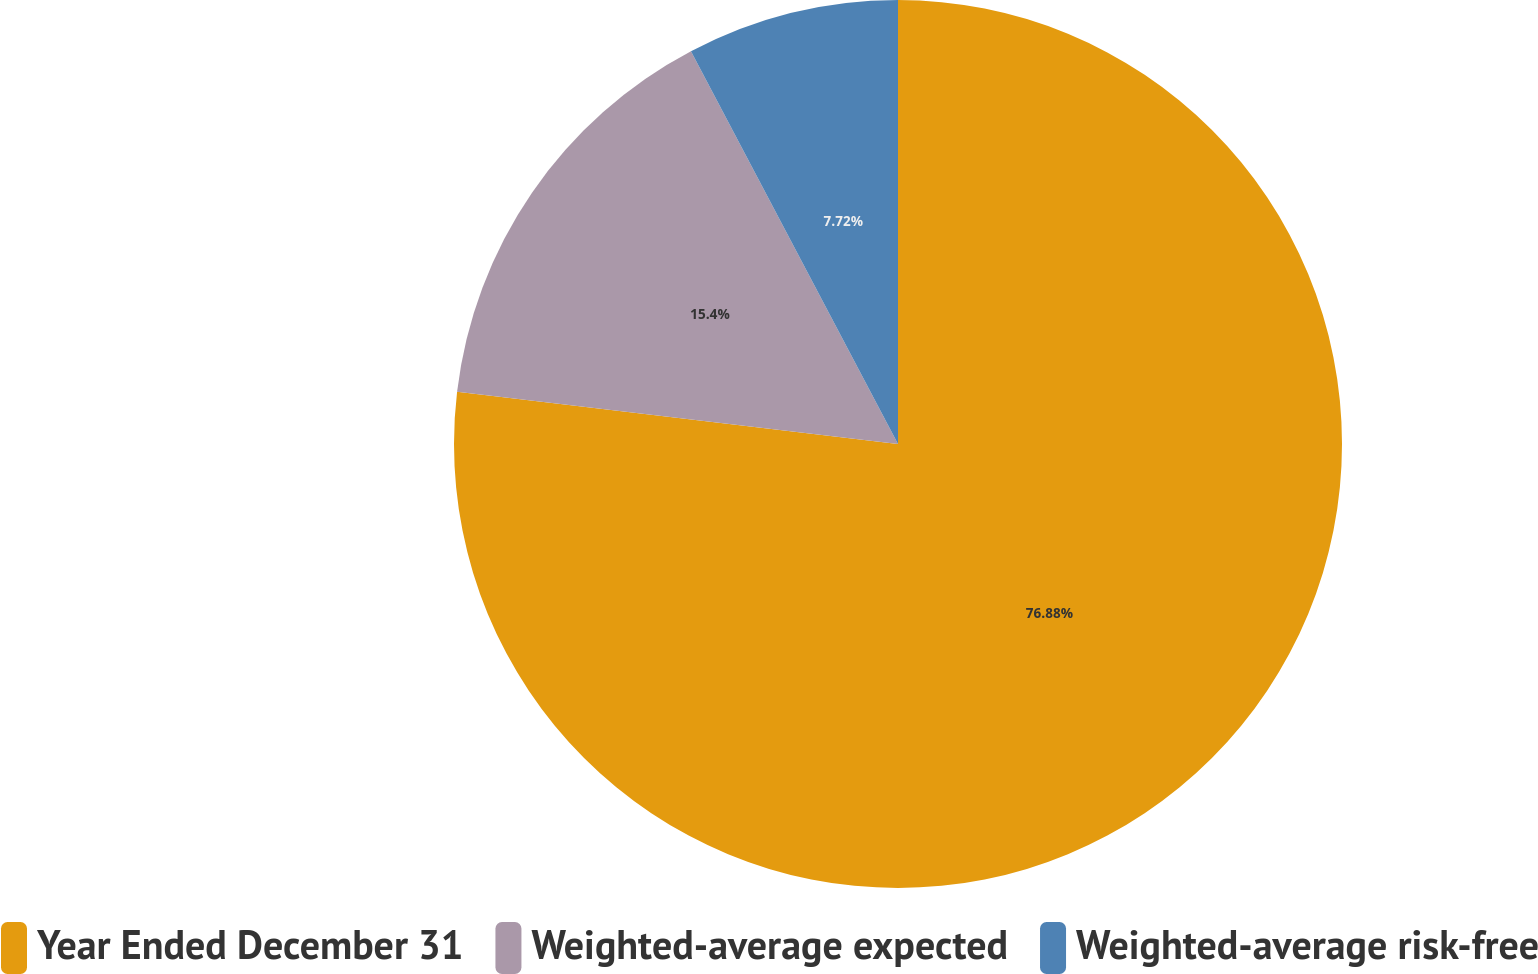<chart> <loc_0><loc_0><loc_500><loc_500><pie_chart><fcel>Year Ended December 31<fcel>Weighted-average expected<fcel>Weighted-average risk-free<nl><fcel>76.87%<fcel>15.4%<fcel>7.72%<nl></chart> 